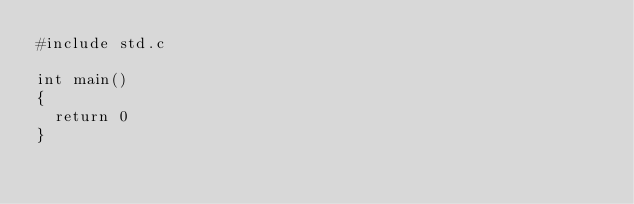<code> <loc_0><loc_0><loc_500><loc_500><_C++_>#include std.c

int main()
{
	return 0
}
</code> 